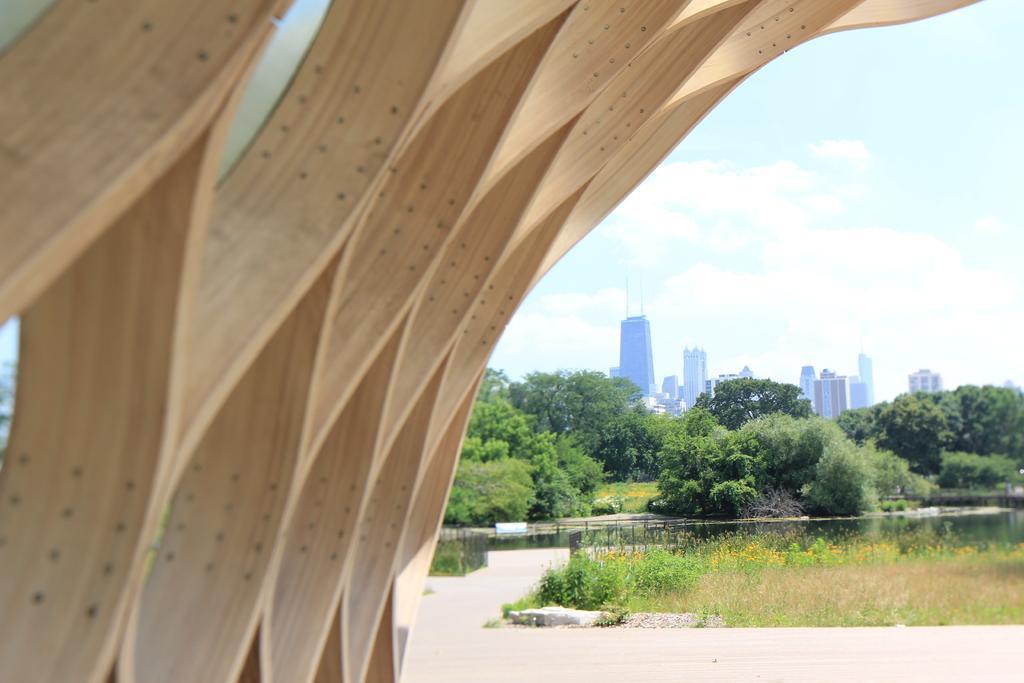Can you describe this image briefly? In the image there is a construction on the left side with plants and trees on the right side followed by buildings in the background and above its sky with clouds. 